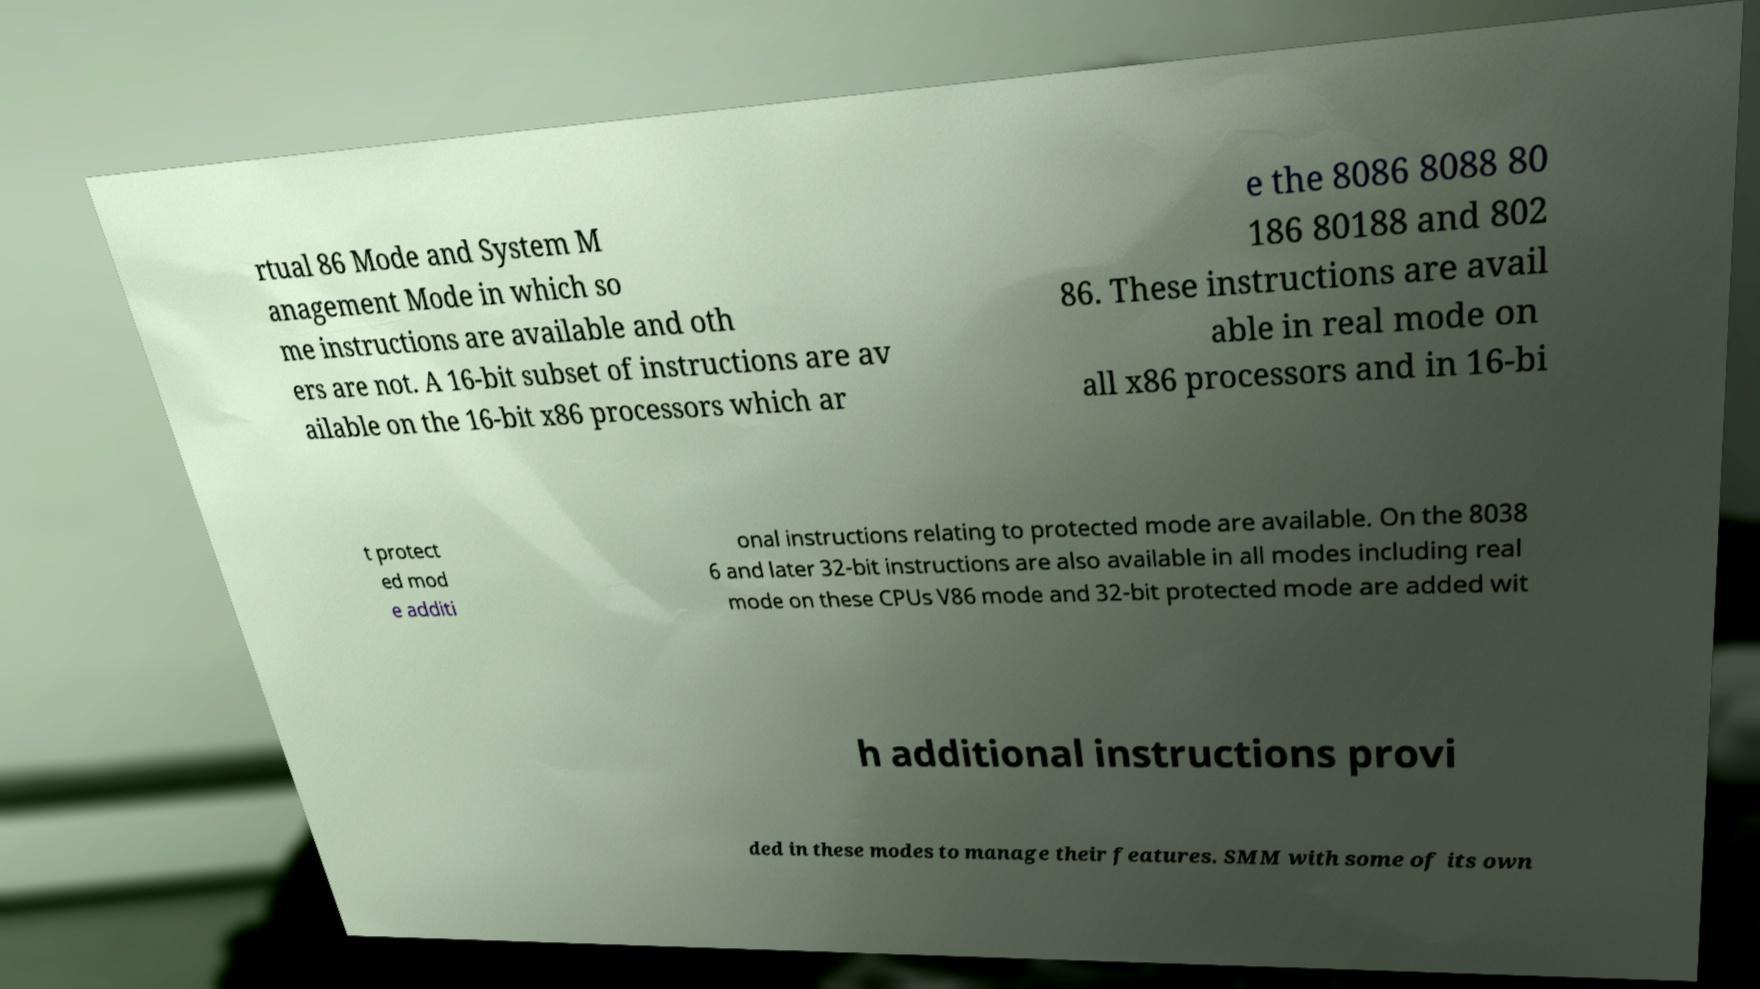Please identify and transcribe the text found in this image. rtual 86 Mode and System M anagement Mode in which so me instructions are available and oth ers are not. A 16-bit subset of instructions are av ailable on the 16-bit x86 processors which ar e the 8086 8088 80 186 80188 and 802 86. These instructions are avail able in real mode on all x86 processors and in 16-bi t protect ed mod e additi onal instructions relating to protected mode are available. On the 8038 6 and later 32-bit instructions are also available in all modes including real mode on these CPUs V86 mode and 32-bit protected mode are added wit h additional instructions provi ded in these modes to manage their features. SMM with some of its own 